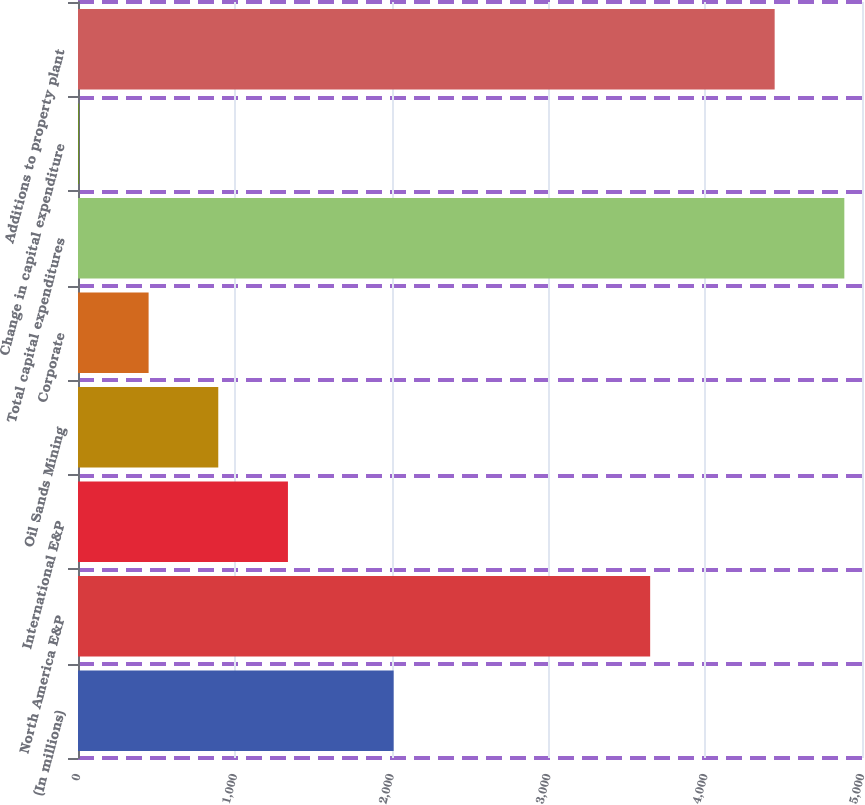Convert chart to OTSL. <chart><loc_0><loc_0><loc_500><loc_500><bar_chart><fcel>(In millions)<fcel>North America E&P<fcel>International E&P<fcel>Oil Sands Mining<fcel>Corporate<fcel>Total capital expenditures<fcel>Change in capital expenditure<fcel>Additions to property plant<nl><fcel>2013<fcel>3649<fcel>1338.9<fcel>894.6<fcel>450.3<fcel>4887.3<fcel>6<fcel>4443<nl></chart> 